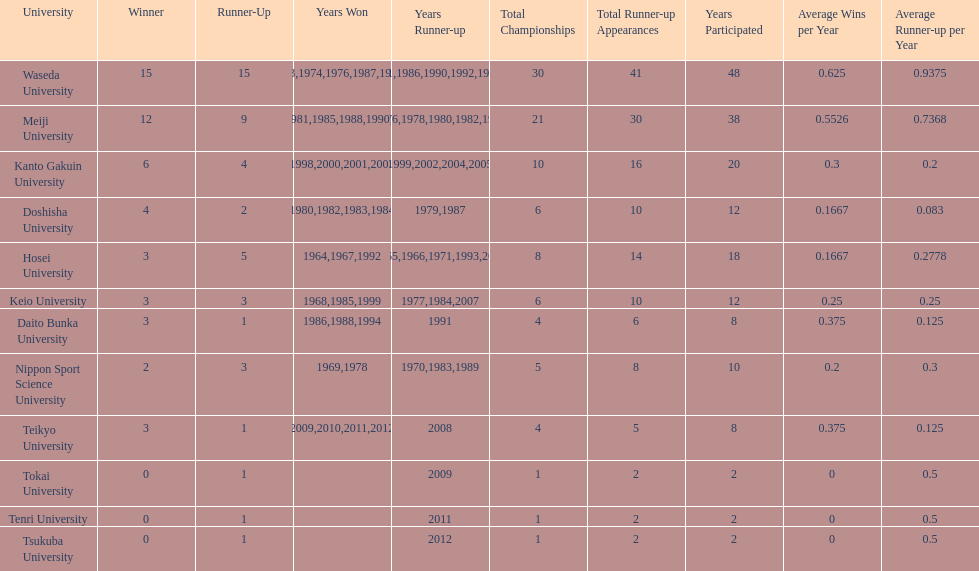Which universities had a number of wins higher than 12? Waseda University. 